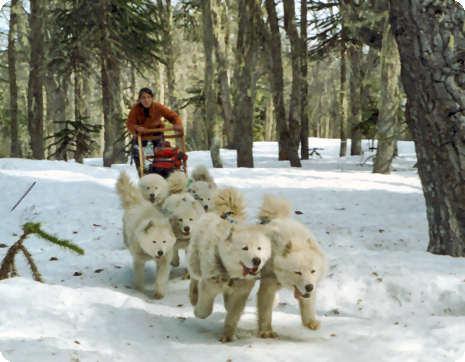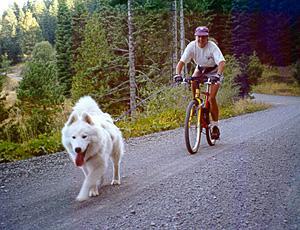The first image is the image on the left, the second image is the image on the right. For the images shown, is this caption "At least one image shows a person in a vehicle behind at least one dog, going down a lane." true? Answer yes or no. Yes. The first image is the image on the left, the second image is the image on the right. Assess this claim about the two images: "In one image, a woman is shown with a white dog and three sheep.". Correct or not? Answer yes or no. No. 